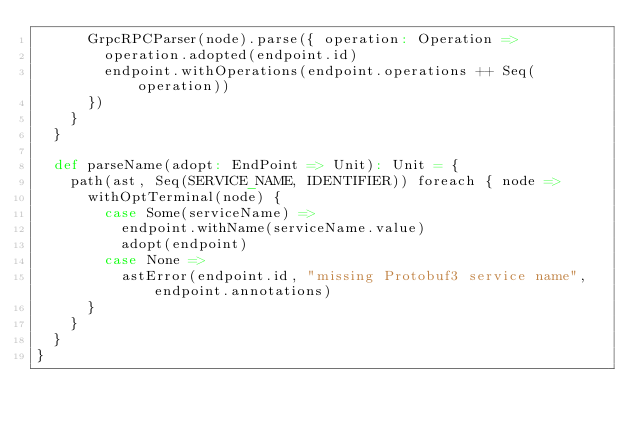Convert code to text. <code><loc_0><loc_0><loc_500><loc_500><_Scala_>      GrpcRPCParser(node).parse({ operation: Operation =>
        operation.adopted(endpoint.id)
        endpoint.withOperations(endpoint.operations ++ Seq(operation))
      })
    }
  }

  def parseName(adopt: EndPoint => Unit): Unit = {
    path(ast, Seq(SERVICE_NAME, IDENTIFIER)) foreach { node =>
      withOptTerminal(node) {
        case Some(serviceName) =>
          endpoint.withName(serviceName.value)
          adopt(endpoint)
        case None =>
          astError(endpoint.id, "missing Protobuf3 service name", endpoint.annotations)
      }
    }
  }
}
</code> 